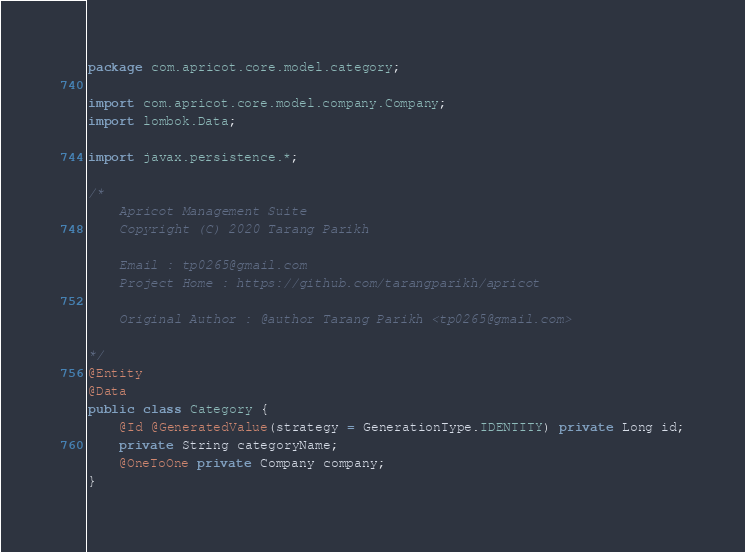<code> <loc_0><loc_0><loc_500><loc_500><_Java_>package com.apricot.core.model.category;

import com.apricot.core.model.company.Company;
import lombok.Data;

import javax.persistence.*;

/*
    Apricot Management Suite
    Copyright (C) 2020 Tarang Parikh

    Email : tp0265@gmail.com
    Project Home : https://github.com/tarangparikh/apricot

    Original Author : @author Tarang Parikh <tp0265@gmail.com>

*/
@Entity
@Data
public class Category {
    @Id @GeneratedValue(strategy = GenerationType.IDENTITY) private Long id;
    private String categoryName;
    @OneToOne private Company company;
}
</code> 